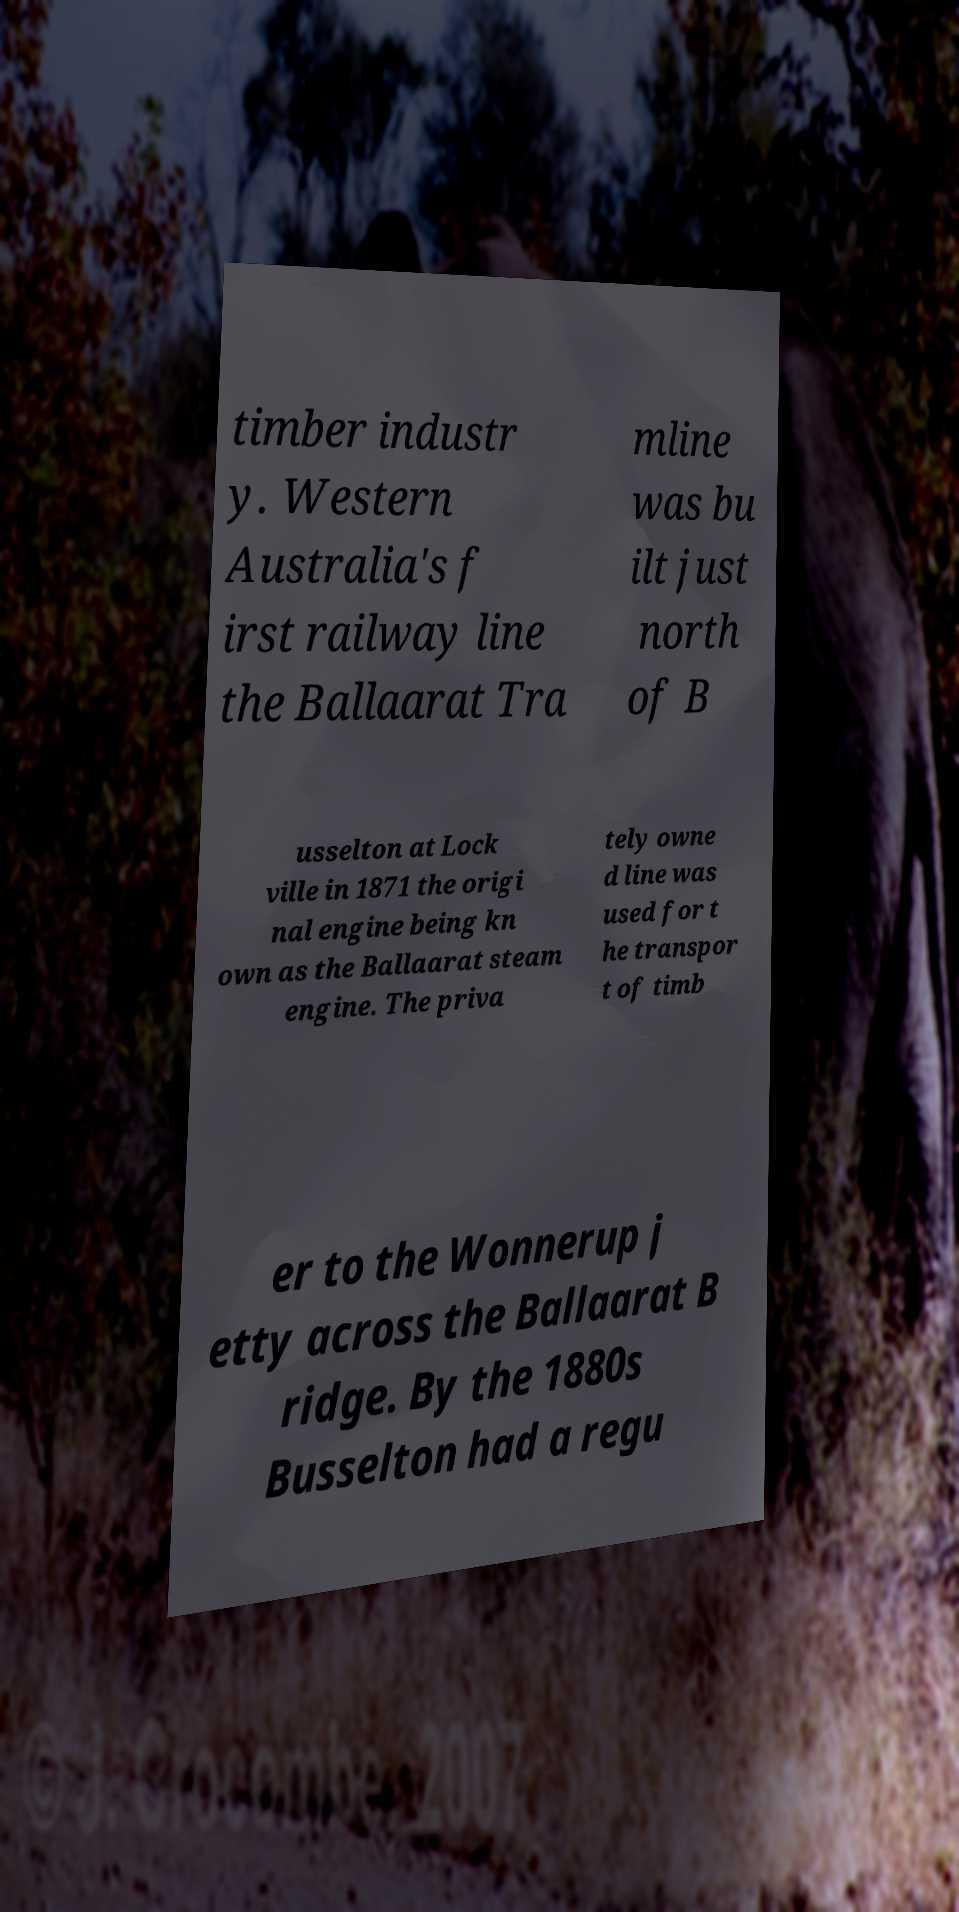I need the written content from this picture converted into text. Can you do that? timber industr y. Western Australia's f irst railway line the Ballaarat Tra mline was bu ilt just north of B usselton at Lock ville in 1871 the origi nal engine being kn own as the Ballaarat steam engine. The priva tely owne d line was used for t he transpor t of timb er to the Wonnerup j etty across the Ballaarat B ridge. By the 1880s Busselton had a regu 